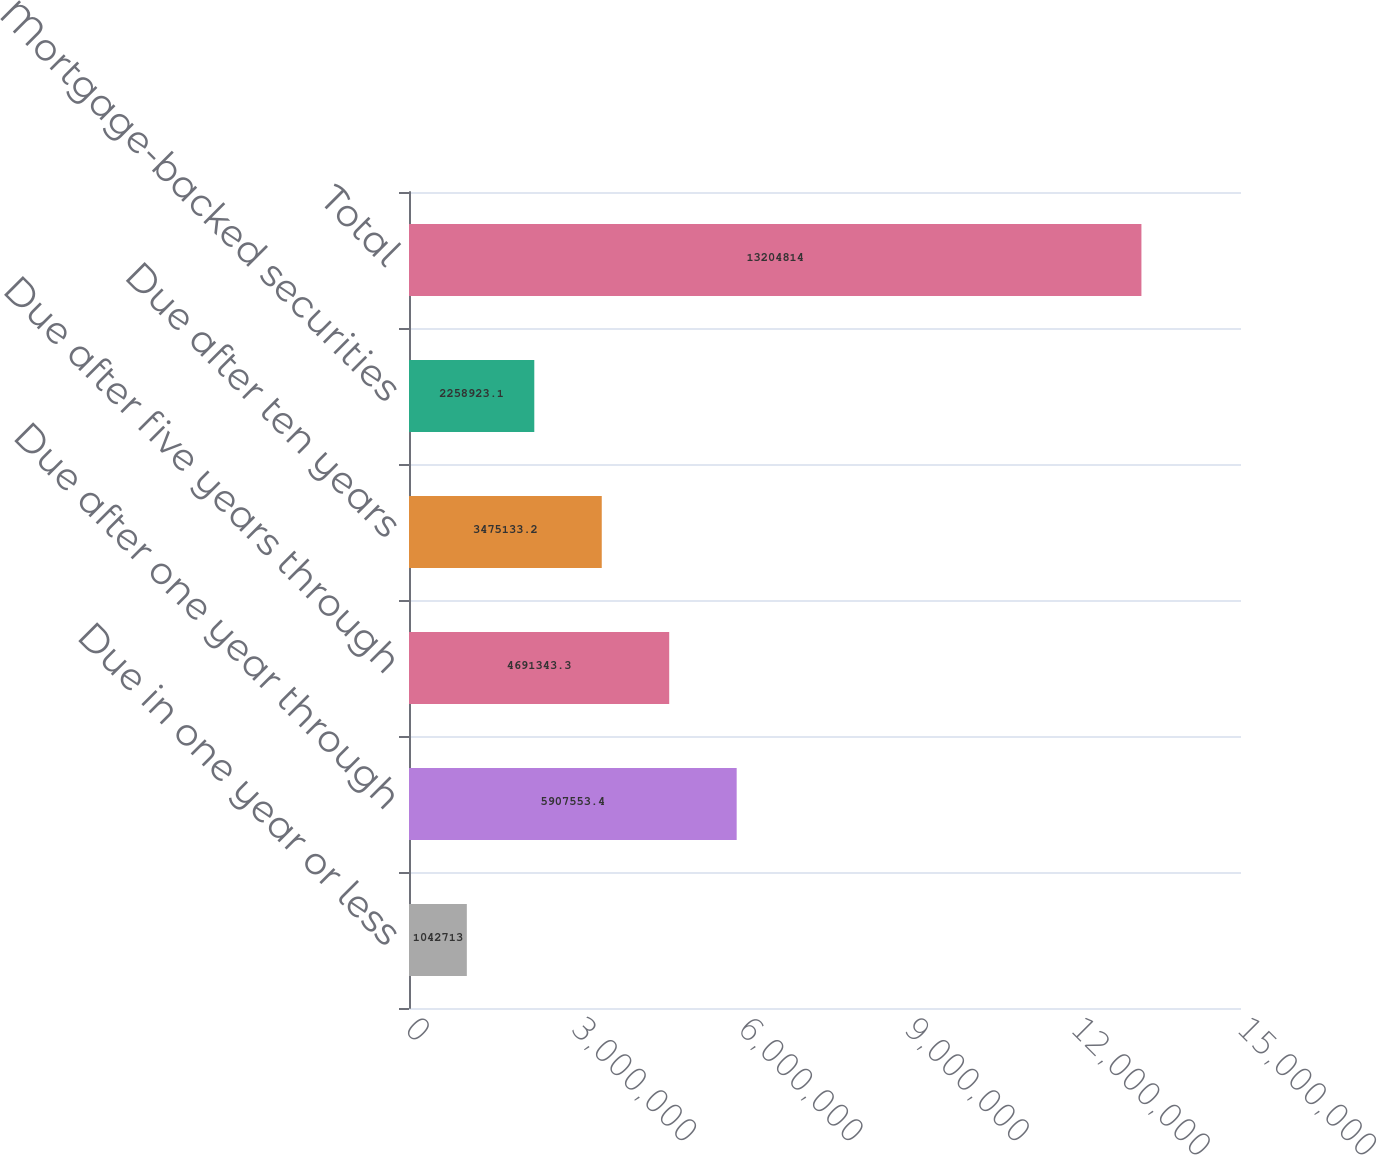Convert chart. <chart><loc_0><loc_0><loc_500><loc_500><bar_chart><fcel>Due in one year or less<fcel>Due after one year through<fcel>Due after five years through<fcel>Due after ten years<fcel>Mortgage-backed securities<fcel>Total<nl><fcel>1.04271e+06<fcel>5.90755e+06<fcel>4.69134e+06<fcel>3.47513e+06<fcel>2.25892e+06<fcel>1.32048e+07<nl></chart> 